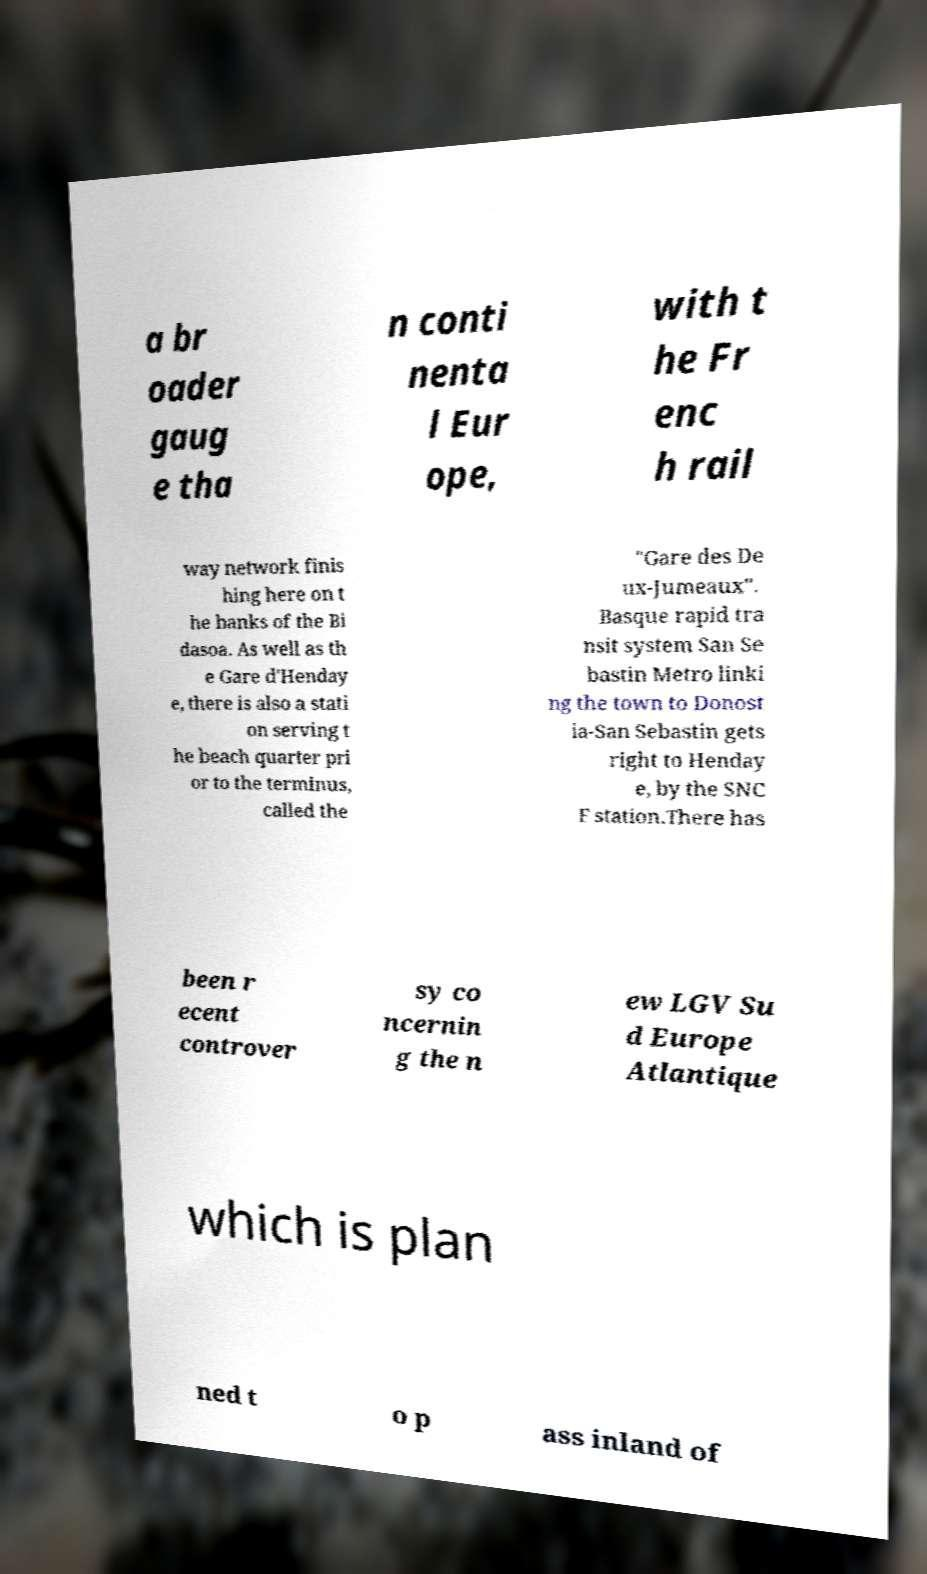What messages or text are displayed in this image? I need them in a readable, typed format. a br oader gaug e tha n conti nenta l Eur ope, with t he Fr enc h rail way network finis hing here on t he banks of the Bi dasoa. As well as th e Gare d'Henday e, there is also a stati on serving t he beach quarter pri or to the terminus, called the "Gare des De ux-Jumeaux". Basque rapid tra nsit system San Se bastin Metro linki ng the town to Donost ia-San Sebastin gets right to Henday e, by the SNC F station.There has been r ecent controver sy co ncernin g the n ew LGV Su d Europe Atlantique which is plan ned t o p ass inland of 